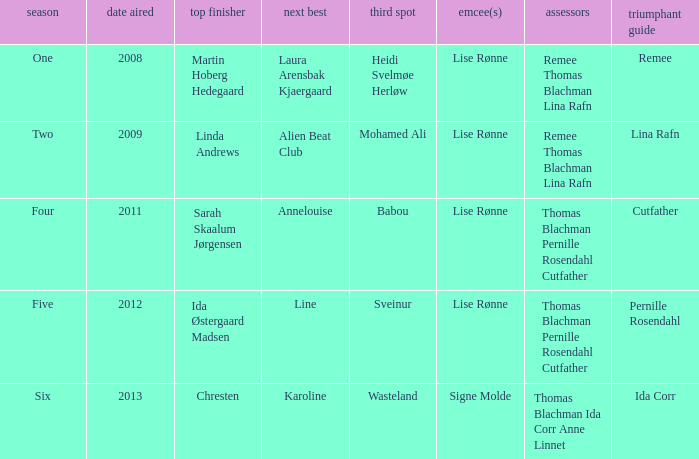Who won third place in season four? Babou. 